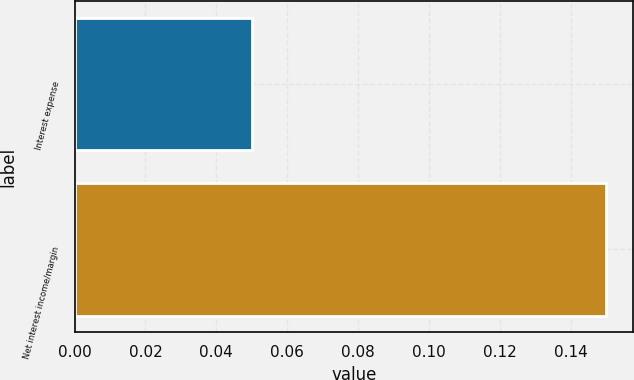Convert chart to OTSL. <chart><loc_0><loc_0><loc_500><loc_500><bar_chart><fcel>Interest expense<fcel>Net interest income/margin<nl><fcel>0.05<fcel>0.15<nl></chart> 